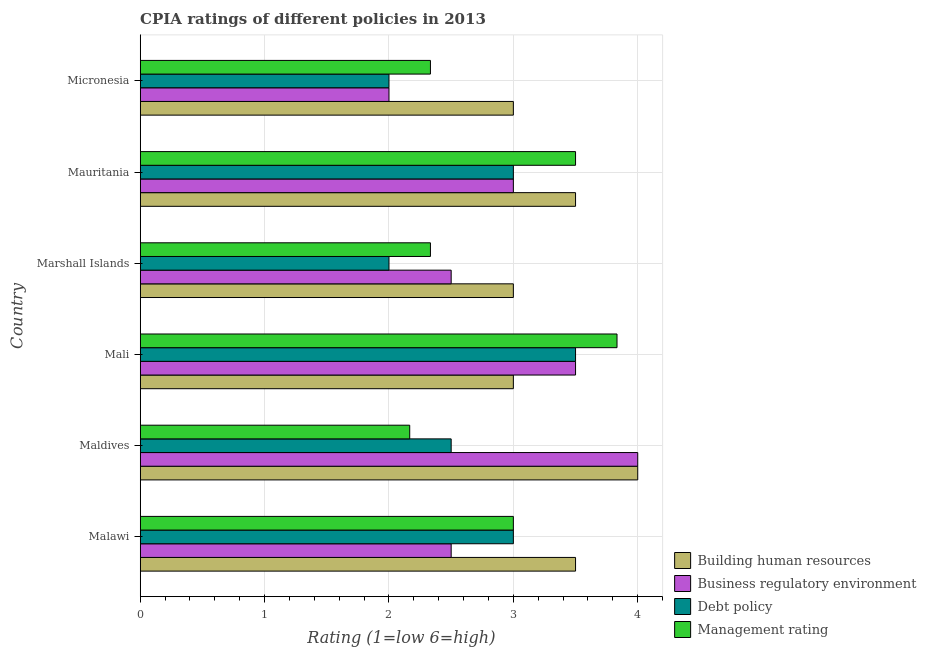How many groups of bars are there?
Your answer should be compact. 6. Are the number of bars per tick equal to the number of legend labels?
Keep it short and to the point. Yes. How many bars are there on the 2nd tick from the top?
Ensure brevity in your answer.  4. How many bars are there on the 3rd tick from the bottom?
Give a very brief answer. 4. What is the label of the 2nd group of bars from the top?
Your answer should be very brief. Mauritania. In how many cases, is the number of bars for a given country not equal to the number of legend labels?
Make the answer very short. 0. Across all countries, what is the minimum cpia rating of management?
Your answer should be very brief. 2.17. In which country was the cpia rating of building human resources maximum?
Provide a short and direct response. Maldives. In which country was the cpia rating of business regulatory environment minimum?
Give a very brief answer. Micronesia. What is the total cpia rating of debt policy in the graph?
Offer a terse response. 16. What is the difference between the cpia rating of management in Mali and that in Micronesia?
Offer a very short reply. 1.5. What is the average cpia rating of management per country?
Offer a terse response. 2.86. What is the difference between the cpia rating of debt policy and cpia rating of management in Mali?
Keep it short and to the point. -0.33. What is the ratio of the cpia rating of debt policy in Mauritania to that in Micronesia?
Ensure brevity in your answer.  1.5. Is the cpia rating of debt policy in Malawi less than that in Mali?
Give a very brief answer. Yes. Is the difference between the cpia rating of management in Malawi and Marshall Islands greater than the difference between the cpia rating of business regulatory environment in Malawi and Marshall Islands?
Your response must be concise. Yes. What is the difference between the highest and the second highest cpia rating of debt policy?
Your response must be concise. 0.5. Is the sum of the cpia rating of building human resources in Maldives and Micronesia greater than the maximum cpia rating of business regulatory environment across all countries?
Your answer should be very brief. Yes. What does the 2nd bar from the top in Mali represents?
Your answer should be very brief. Debt policy. What does the 3rd bar from the bottom in Mali represents?
Offer a terse response. Debt policy. How many bars are there?
Give a very brief answer. 24. How many countries are there in the graph?
Give a very brief answer. 6. What is the difference between two consecutive major ticks on the X-axis?
Your answer should be compact. 1. Are the values on the major ticks of X-axis written in scientific E-notation?
Your response must be concise. No. Does the graph contain any zero values?
Your response must be concise. No. How are the legend labels stacked?
Make the answer very short. Vertical. What is the title of the graph?
Your answer should be compact. CPIA ratings of different policies in 2013. What is the label or title of the Y-axis?
Your answer should be compact. Country. What is the Rating (1=low 6=high) in Building human resources in Malawi?
Provide a succinct answer. 3.5. What is the Rating (1=low 6=high) of Business regulatory environment in Maldives?
Provide a succinct answer. 4. What is the Rating (1=low 6=high) of Management rating in Maldives?
Your response must be concise. 2.17. What is the Rating (1=low 6=high) in Business regulatory environment in Mali?
Provide a succinct answer. 3.5. What is the Rating (1=low 6=high) in Debt policy in Mali?
Provide a succinct answer. 3.5. What is the Rating (1=low 6=high) of Management rating in Mali?
Offer a terse response. 3.83. What is the Rating (1=low 6=high) in Business regulatory environment in Marshall Islands?
Your response must be concise. 2.5. What is the Rating (1=low 6=high) in Debt policy in Marshall Islands?
Your answer should be compact. 2. What is the Rating (1=low 6=high) in Management rating in Marshall Islands?
Offer a terse response. 2.33. What is the Rating (1=low 6=high) in Business regulatory environment in Mauritania?
Give a very brief answer. 3. What is the Rating (1=low 6=high) of Debt policy in Mauritania?
Give a very brief answer. 3. What is the Rating (1=low 6=high) in Management rating in Micronesia?
Your response must be concise. 2.33. Across all countries, what is the maximum Rating (1=low 6=high) in Building human resources?
Your response must be concise. 4. Across all countries, what is the maximum Rating (1=low 6=high) in Management rating?
Ensure brevity in your answer.  3.83. Across all countries, what is the minimum Rating (1=low 6=high) in Business regulatory environment?
Offer a very short reply. 2. Across all countries, what is the minimum Rating (1=low 6=high) of Debt policy?
Give a very brief answer. 2. Across all countries, what is the minimum Rating (1=low 6=high) of Management rating?
Ensure brevity in your answer.  2.17. What is the total Rating (1=low 6=high) of Building human resources in the graph?
Give a very brief answer. 20. What is the total Rating (1=low 6=high) of Business regulatory environment in the graph?
Make the answer very short. 17.5. What is the total Rating (1=low 6=high) in Management rating in the graph?
Make the answer very short. 17.17. What is the difference between the Rating (1=low 6=high) in Building human resources in Malawi and that in Maldives?
Offer a terse response. -0.5. What is the difference between the Rating (1=low 6=high) in Debt policy in Malawi and that in Maldives?
Offer a terse response. 0.5. What is the difference between the Rating (1=low 6=high) in Management rating in Malawi and that in Maldives?
Keep it short and to the point. 0.83. What is the difference between the Rating (1=low 6=high) in Debt policy in Malawi and that in Mali?
Offer a very short reply. -0.5. What is the difference between the Rating (1=low 6=high) of Management rating in Malawi and that in Mali?
Ensure brevity in your answer.  -0.83. What is the difference between the Rating (1=low 6=high) of Building human resources in Malawi and that in Marshall Islands?
Keep it short and to the point. 0.5. What is the difference between the Rating (1=low 6=high) in Business regulatory environment in Malawi and that in Marshall Islands?
Your response must be concise. 0. What is the difference between the Rating (1=low 6=high) of Debt policy in Malawi and that in Marshall Islands?
Provide a short and direct response. 1. What is the difference between the Rating (1=low 6=high) of Building human resources in Malawi and that in Mauritania?
Your response must be concise. 0. What is the difference between the Rating (1=low 6=high) of Debt policy in Malawi and that in Micronesia?
Keep it short and to the point. 1. What is the difference between the Rating (1=low 6=high) in Management rating in Malawi and that in Micronesia?
Your response must be concise. 0.67. What is the difference between the Rating (1=low 6=high) in Business regulatory environment in Maldives and that in Mali?
Keep it short and to the point. 0.5. What is the difference between the Rating (1=low 6=high) in Debt policy in Maldives and that in Mali?
Provide a short and direct response. -1. What is the difference between the Rating (1=low 6=high) of Management rating in Maldives and that in Mali?
Give a very brief answer. -1.67. What is the difference between the Rating (1=low 6=high) of Building human resources in Maldives and that in Marshall Islands?
Ensure brevity in your answer.  1. What is the difference between the Rating (1=low 6=high) of Management rating in Maldives and that in Marshall Islands?
Provide a succinct answer. -0.17. What is the difference between the Rating (1=low 6=high) in Management rating in Maldives and that in Mauritania?
Keep it short and to the point. -1.33. What is the difference between the Rating (1=low 6=high) of Business regulatory environment in Maldives and that in Micronesia?
Provide a short and direct response. 2. What is the difference between the Rating (1=low 6=high) of Building human resources in Mali and that in Marshall Islands?
Provide a short and direct response. 0. What is the difference between the Rating (1=low 6=high) in Debt policy in Mali and that in Marshall Islands?
Offer a terse response. 1.5. What is the difference between the Rating (1=low 6=high) in Business regulatory environment in Mali and that in Mauritania?
Ensure brevity in your answer.  0.5. What is the difference between the Rating (1=low 6=high) of Business regulatory environment in Mali and that in Micronesia?
Offer a terse response. 1.5. What is the difference between the Rating (1=low 6=high) of Management rating in Mali and that in Micronesia?
Give a very brief answer. 1.5. What is the difference between the Rating (1=low 6=high) in Building human resources in Marshall Islands and that in Mauritania?
Offer a terse response. -0.5. What is the difference between the Rating (1=low 6=high) of Business regulatory environment in Marshall Islands and that in Mauritania?
Give a very brief answer. -0.5. What is the difference between the Rating (1=low 6=high) of Debt policy in Marshall Islands and that in Mauritania?
Ensure brevity in your answer.  -1. What is the difference between the Rating (1=low 6=high) in Management rating in Marshall Islands and that in Mauritania?
Offer a very short reply. -1.17. What is the difference between the Rating (1=low 6=high) in Building human resources in Marshall Islands and that in Micronesia?
Provide a succinct answer. 0. What is the difference between the Rating (1=low 6=high) of Business regulatory environment in Marshall Islands and that in Micronesia?
Provide a succinct answer. 0.5. What is the difference between the Rating (1=low 6=high) of Debt policy in Mauritania and that in Micronesia?
Provide a short and direct response. 1. What is the difference between the Rating (1=low 6=high) in Management rating in Mauritania and that in Micronesia?
Offer a very short reply. 1.17. What is the difference between the Rating (1=low 6=high) of Business regulatory environment in Malawi and the Rating (1=low 6=high) of Debt policy in Maldives?
Provide a succinct answer. 0. What is the difference between the Rating (1=low 6=high) in Business regulatory environment in Malawi and the Rating (1=low 6=high) in Management rating in Maldives?
Make the answer very short. 0.33. What is the difference between the Rating (1=low 6=high) in Debt policy in Malawi and the Rating (1=low 6=high) in Management rating in Maldives?
Give a very brief answer. 0.83. What is the difference between the Rating (1=low 6=high) of Building human resources in Malawi and the Rating (1=low 6=high) of Business regulatory environment in Mali?
Offer a very short reply. 0. What is the difference between the Rating (1=low 6=high) in Building human resources in Malawi and the Rating (1=low 6=high) in Debt policy in Mali?
Keep it short and to the point. 0. What is the difference between the Rating (1=low 6=high) in Building human resources in Malawi and the Rating (1=low 6=high) in Management rating in Mali?
Your answer should be compact. -0.33. What is the difference between the Rating (1=low 6=high) of Business regulatory environment in Malawi and the Rating (1=low 6=high) of Debt policy in Mali?
Ensure brevity in your answer.  -1. What is the difference between the Rating (1=low 6=high) in Business regulatory environment in Malawi and the Rating (1=low 6=high) in Management rating in Mali?
Offer a very short reply. -1.33. What is the difference between the Rating (1=low 6=high) in Building human resources in Malawi and the Rating (1=low 6=high) in Business regulatory environment in Marshall Islands?
Give a very brief answer. 1. What is the difference between the Rating (1=low 6=high) of Building human resources in Malawi and the Rating (1=low 6=high) of Management rating in Marshall Islands?
Offer a terse response. 1.17. What is the difference between the Rating (1=low 6=high) of Business regulatory environment in Malawi and the Rating (1=low 6=high) of Debt policy in Marshall Islands?
Make the answer very short. 0.5. What is the difference between the Rating (1=low 6=high) in Building human resources in Malawi and the Rating (1=low 6=high) in Business regulatory environment in Mauritania?
Offer a terse response. 0.5. What is the difference between the Rating (1=low 6=high) in Building human resources in Malawi and the Rating (1=low 6=high) in Business regulatory environment in Micronesia?
Give a very brief answer. 1.5. What is the difference between the Rating (1=low 6=high) of Building human resources in Maldives and the Rating (1=low 6=high) of Business regulatory environment in Mali?
Your answer should be compact. 0.5. What is the difference between the Rating (1=low 6=high) in Building human resources in Maldives and the Rating (1=low 6=high) in Debt policy in Mali?
Make the answer very short. 0.5. What is the difference between the Rating (1=low 6=high) of Debt policy in Maldives and the Rating (1=low 6=high) of Management rating in Mali?
Give a very brief answer. -1.33. What is the difference between the Rating (1=low 6=high) of Building human resources in Maldives and the Rating (1=low 6=high) of Business regulatory environment in Marshall Islands?
Provide a succinct answer. 1.5. What is the difference between the Rating (1=low 6=high) of Building human resources in Maldives and the Rating (1=low 6=high) of Debt policy in Marshall Islands?
Keep it short and to the point. 2. What is the difference between the Rating (1=low 6=high) in Business regulatory environment in Maldives and the Rating (1=low 6=high) in Management rating in Marshall Islands?
Offer a terse response. 1.67. What is the difference between the Rating (1=low 6=high) in Business regulatory environment in Maldives and the Rating (1=low 6=high) in Management rating in Mauritania?
Give a very brief answer. 0.5. What is the difference between the Rating (1=low 6=high) in Business regulatory environment in Maldives and the Rating (1=low 6=high) in Management rating in Micronesia?
Your answer should be very brief. 1.67. What is the difference between the Rating (1=low 6=high) of Building human resources in Mali and the Rating (1=low 6=high) of Business regulatory environment in Marshall Islands?
Ensure brevity in your answer.  0.5. What is the difference between the Rating (1=low 6=high) in Building human resources in Mali and the Rating (1=low 6=high) in Debt policy in Marshall Islands?
Make the answer very short. 1. What is the difference between the Rating (1=low 6=high) in Business regulatory environment in Mali and the Rating (1=low 6=high) in Debt policy in Marshall Islands?
Your answer should be very brief. 1.5. What is the difference between the Rating (1=low 6=high) of Building human resources in Mali and the Rating (1=low 6=high) of Management rating in Mauritania?
Offer a terse response. -0.5. What is the difference between the Rating (1=low 6=high) in Business regulatory environment in Mali and the Rating (1=low 6=high) in Debt policy in Mauritania?
Your answer should be very brief. 0.5. What is the difference between the Rating (1=low 6=high) of Building human resources in Mali and the Rating (1=low 6=high) of Debt policy in Micronesia?
Make the answer very short. 1. What is the difference between the Rating (1=low 6=high) of Building human resources in Mali and the Rating (1=low 6=high) of Management rating in Micronesia?
Your answer should be compact. 0.67. What is the difference between the Rating (1=low 6=high) of Business regulatory environment in Mali and the Rating (1=low 6=high) of Management rating in Micronesia?
Keep it short and to the point. 1.17. What is the difference between the Rating (1=low 6=high) of Building human resources in Marshall Islands and the Rating (1=low 6=high) of Business regulatory environment in Mauritania?
Your response must be concise. 0. What is the difference between the Rating (1=low 6=high) of Building human resources in Marshall Islands and the Rating (1=low 6=high) of Business regulatory environment in Micronesia?
Your answer should be compact. 1. What is the difference between the Rating (1=low 6=high) of Building human resources in Marshall Islands and the Rating (1=low 6=high) of Debt policy in Micronesia?
Your answer should be very brief. 1. What is the difference between the Rating (1=low 6=high) of Building human resources in Marshall Islands and the Rating (1=low 6=high) of Management rating in Micronesia?
Your response must be concise. 0.67. What is the difference between the Rating (1=low 6=high) in Debt policy in Marshall Islands and the Rating (1=low 6=high) in Management rating in Micronesia?
Your answer should be compact. -0.33. What is the difference between the Rating (1=low 6=high) in Building human resources in Mauritania and the Rating (1=low 6=high) in Management rating in Micronesia?
Make the answer very short. 1.17. What is the difference between the Rating (1=low 6=high) of Business regulatory environment in Mauritania and the Rating (1=low 6=high) of Management rating in Micronesia?
Provide a short and direct response. 0.67. What is the difference between the Rating (1=low 6=high) of Debt policy in Mauritania and the Rating (1=low 6=high) of Management rating in Micronesia?
Give a very brief answer. 0.67. What is the average Rating (1=low 6=high) of Business regulatory environment per country?
Your response must be concise. 2.92. What is the average Rating (1=low 6=high) in Debt policy per country?
Ensure brevity in your answer.  2.67. What is the average Rating (1=low 6=high) in Management rating per country?
Make the answer very short. 2.86. What is the difference between the Rating (1=low 6=high) of Building human resources and Rating (1=low 6=high) of Management rating in Malawi?
Offer a terse response. 0.5. What is the difference between the Rating (1=low 6=high) in Business regulatory environment and Rating (1=low 6=high) in Management rating in Malawi?
Provide a short and direct response. -0.5. What is the difference between the Rating (1=low 6=high) of Building human resources and Rating (1=low 6=high) of Management rating in Maldives?
Your answer should be very brief. 1.83. What is the difference between the Rating (1=low 6=high) of Business regulatory environment and Rating (1=low 6=high) of Management rating in Maldives?
Offer a terse response. 1.83. What is the difference between the Rating (1=low 6=high) in Debt policy and Rating (1=low 6=high) in Management rating in Maldives?
Ensure brevity in your answer.  0.33. What is the difference between the Rating (1=low 6=high) in Building human resources and Rating (1=low 6=high) in Business regulatory environment in Mali?
Offer a terse response. -0.5. What is the difference between the Rating (1=low 6=high) in Building human resources and Rating (1=low 6=high) in Debt policy in Mali?
Provide a succinct answer. -0.5. What is the difference between the Rating (1=low 6=high) in Building human resources and Rating (1=low 6=high) in Management rating in Mali?
Keep it short and to the point. -0.83. What is the difference between the Rating (1=low 6=high) of Debt policy and Rating (1=low 6=high) of Management rating in Mali?
Your answer should be very brief. -0.33. What is the difference between the Rating (1=low 6=high) of Building human resources and Rating (1=low 6=high) of Business regulatory environment in Marshall Islands?
Provide a succinct answer. 0.5. What is the difference between the Rating (1=low 6=high) in Building human resources and Rating (1=low 6=high) in Debt policy in Marshall Islands?
Give a very brief answer. 1. What is the difference between the Rating (1=low 6=high) in Building human resources and Rating (1=low 6=high) in Debt policy in Mauritania?
Provide a short and direct response. 0.5. What is the difference between the Rating (1=low 6=high) in Building human resources and Rating (1=low 6=high) in Management rating in Mauritania?
Give a very brief answer. 0. What is the difference between the Rating (1=low 6=high) of Business regulatory environment and Rating (1=low 6=high) of Debt policy in Mauritania?
Provide a short and direct response. 0. What is the difference between the Rating (1=low 6=high) of Debt policy and Rating (1=low 6=high) of Management rating in Mauritania?
Your answer should be very brief. -0.5. What is the difference between the Rating (1=low 6=high) of Building human resources and Rating (1=low 6=high) of Debt policy in Micronesia?
Give a very brief answer. 1. What is the difference between the Rating (1=low 6=high) of Building human resources and Rating (1=low 6=high) of Management rating in Micronesia?
Your answer should be compact. 0.67. What is the difference between the Rating (1=low 6=high) in Business regulatory environment and Rating (1=low 6=high) in Debt policy in Micronesia?
Your answer should be very brief. 0. What is the difference between the Rating (1=low 6=high) in Business regulatory environment and Rating (1=low 6=high) in Management rating in Micronesia?
Provide a succinct answer. -0.33. What is the difference between the Rating (1=low 6=high) in Debt policy and Rating (1=low 6=high) in Management rating in Micronesia?
Give a very brief answer. -0.33. What is the ratio of the Rating (1=low 6=high) of Building human resources in Malawi to that in Maldives?
Your answer should be very brief. 0.88. What is the ratio of the Rating (1=low 6=high) of Management rating in Malawi to that in Maldives?
Give a very brief answer. 1.38. What is the ratio of the Rating (1=low 6=high) in Building human resources in Malawi to that in Mali?
Your answer should be very brief. 1.17. What is the ratio of the Rating (1=low 6=high) in Management rating in Malawi to that in Mali?
Provide a succinct answer. 0.78. What is the ratio of the Rating (1=low 6=high) in Building human resources in Malawi to that in Marshall Islands?
Your answer should be compact. 1.17. What is the ratio of the Rating (1=low 6=high) of Business regulatory environment in Malawi to that in Marshall Islands?
Your response must be concise. 1. What is the ratio of the Rating (1=low 6=high) of Debt policy in Malawi to that in Mauritania?
Offer a terse response. 1. What is the ratio of the Rating (1=low 6=high) in Building human resources in Malawi to that in Micronesia?
Your answer should be compact. 1.17. What is the ratio of the Rating (1=low 6=high) of Debt policy in Malawi to that in Micronesia?
Provide a short and direct response. 1.5. What is the ratio of the Rating (1=low 6=high) of Management rating in Maldives to that in Mali?
Keep it short and to the point. 0.57. What is the ratio of the Rating (1=low 6=high) in Building human resources in Maldives to that in Marshall Islands?
Keep it short and to the point. 1.33. What is the ratio of the Rating (1=low 6=high) of Debt policy in Maldives to that in Marshall Islands?
Offer a terse response. 1.25. What is the ratio of the Rating (1=low 6=high) in Management rating in Maldives to that in Marshall Islands?
Ensure brevity in your answer.  0.93. What is the ratio of the Rating (1=low 6=high) of Building human resources in Maldives to that in Mauritania?
Provide a short and direct response. 1.14. What is the ratio of the Rating (1=low 6=high) of Debt policy in Maldives to that in Mauritania?
Ensure brevity in your answer.  0.83. What is the ratio of the Rating (1=low 6=high) in Management rating in Maldives to that in Mauritania?
Your answer should be compact. 0.62. What is the ratio of the Rating (1=low 6=high) of Business regulatory environment in Maldives to that in Micronesia?
Keep it short and to the point. 2. What is the ratio of the Rating (1=low 6=high) in Debt policy in Maldives to that in Micronesia?
Provide a short and direct response. 1.25. What is the ratio of the Rating (1=low 6=high) in Business regulatory environment in Mali to that in Marshall Islands?
Provide a succinct answer. 1.4. What is the ratio of the Rating (1=low 6=high) of Debt policy in Mali to that in Marshall Islands?
Offer a very short reply. 1.75. What is the ratio of the Rating (1=low 6=high) in Management rating in Mali to that in Marshall Islands?
Your answer should be very brief. 1.64. What is the ratio of the Rating (1=low 6=high) of Management rating in Mali to that in Mauritania?
Your answer should be very brief. 1.1. What is the ratio of the Rating (1=low 6=high) in Management rating in Mali to that in Micronesia?
Provide a succinct answer. 1.64. What is the ratio of the Rating (1=low 6=high) in Building human resources in Marshall Islands to that in Mauritania?
Provide a succinct answer. 0.86. What is the ratio of the Rating (1=low 6=high) in Business regulatory environment in Marshall Islands to that in Micronesia?
Make the answer very short. 1.25. What is the ratio of the Rating (1=low 6=high) of Business regulatory environment in Mauritania to that in Micronesia?
Make the answer very short. 1.5. What is the ratio of the Rating (1=low 6=high) in Management rating in Mauritania to that in Micronesia?
Offer a very short reply. 1.5. What is the difference between the highest and the second highest Rating (1=low 6=high) in Building human resources?
Your answer should be very brief. 0.5. What is the difference between the highest and the second highest Rating (1=low 6=high) in Business regulatory environment?
Your answer should be very brief. 0.5. What is the difference between the highest and the second highest Rating (1=low 6=high) of Management rating?
Ensure brevity in your answer.  0.33. What is the difference between the highest and the lowest Rating (1=low 6=high) of Building human resources?
Provide a short and direct response. 1. What is the difference between the highest and the lowest Rating (1=low 6=high) of Business regulatory environment?
Your answer should be very brief. 2. 